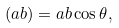Convert formula to latex. <formula><loc_0><loc_0><loc_500><loc_500>( a b ) = a b \cos \theta ,</formula> 